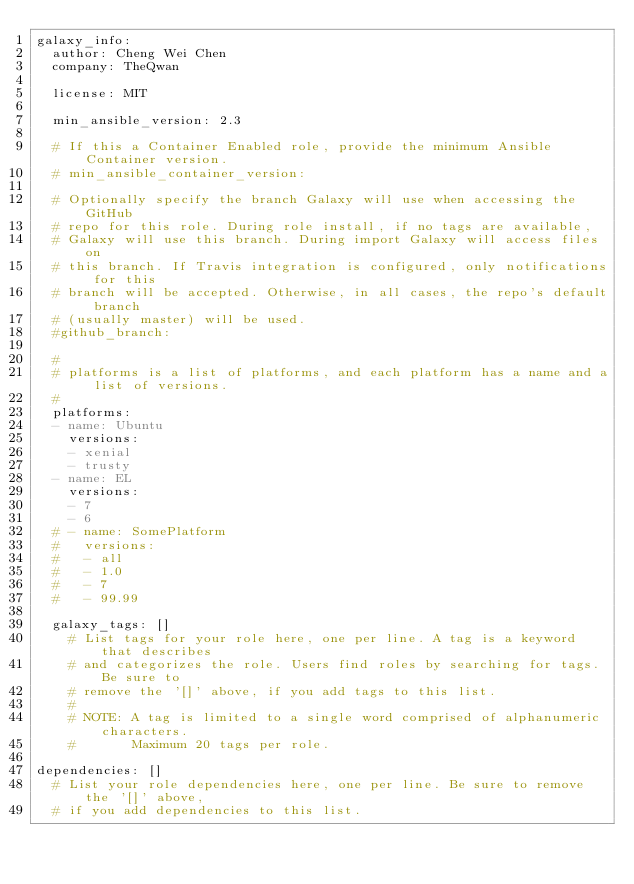Convert code to text. <code><loc_0><loc_0><loc_500><loc_500><_YAML_>galaxy_info:
  author: Cheng Wei Chen
  company: TheQwan

  license: MIT

  min_ansible_version: 2.3

  # If this a Container Enabled role, provide the minimum Ansible Container version.
  # min_ansible_container_version:

  # Optionally specify the branch Galaxy will use when accessing the GitHub
  # repo for this role. During role install, if no tags are available,
  # Galaxy will use this branch. During import Galaxy will access files on
  # this branch. If Travis integration is configured, only notifications for this
  # branch will be accepted. Otherwise, in all cases, the repo's default branch
  # (usually master) will be used.
  #github_branch:

  #
  # platforms is a list of platforms, and each platform has a name and a list of versions.
  #
  platforms:
  - name: Ubuntu
    versions:
    - xenial
    - trusty
  - name: EL
    versions:
    - 7
    - 6
  # - name: SomePlatform
  #   versions:
  #   - all
  #   - 1.0
  #   - 7
  #   - 99.99

  galaxy_tags: []
    # List tags for your role here, one per line. A tag is a keyword that describes
    # and categorizes the role. Users find roles by searching for tags. Be sure to
    # remove the '[]' above, if you add tags to this list.
    #
    # NOTE: A tag is limited to a single word comprised of alphanumeric characters.
    #       Maximum 20 tags per role.

dependencies: []
  # List your role dependencies here, one per line. Be sure to remove the '[]' above,
  # if you add dependencies to this list.
</code> 